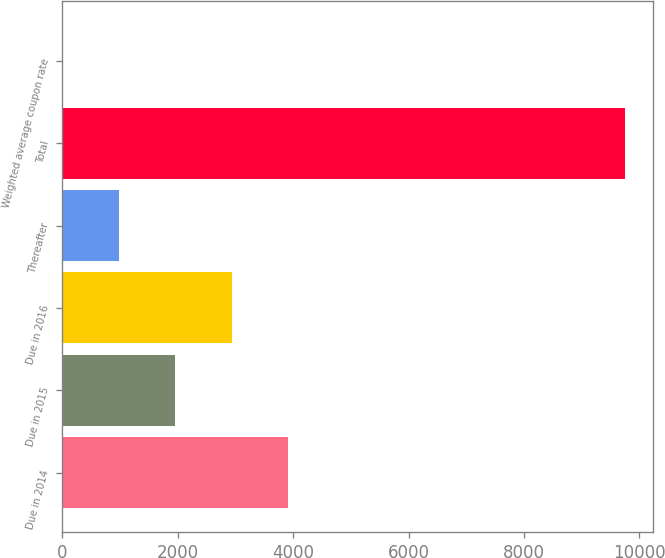<chart> <loc_0><loc_0><loc_500><loc_500><bar_chart><fcel>Due in 2014<fcel>Due in 2015<fcel>Due in 2016<fcel>Thereafter<fcel>Total<fcel>Weighted average coupon rate<nl><fcel>3916.86<fcel>1951.12<fcel>2942<fcel>976.26<fcel>9750<fcel>1.4<nl></chart> 